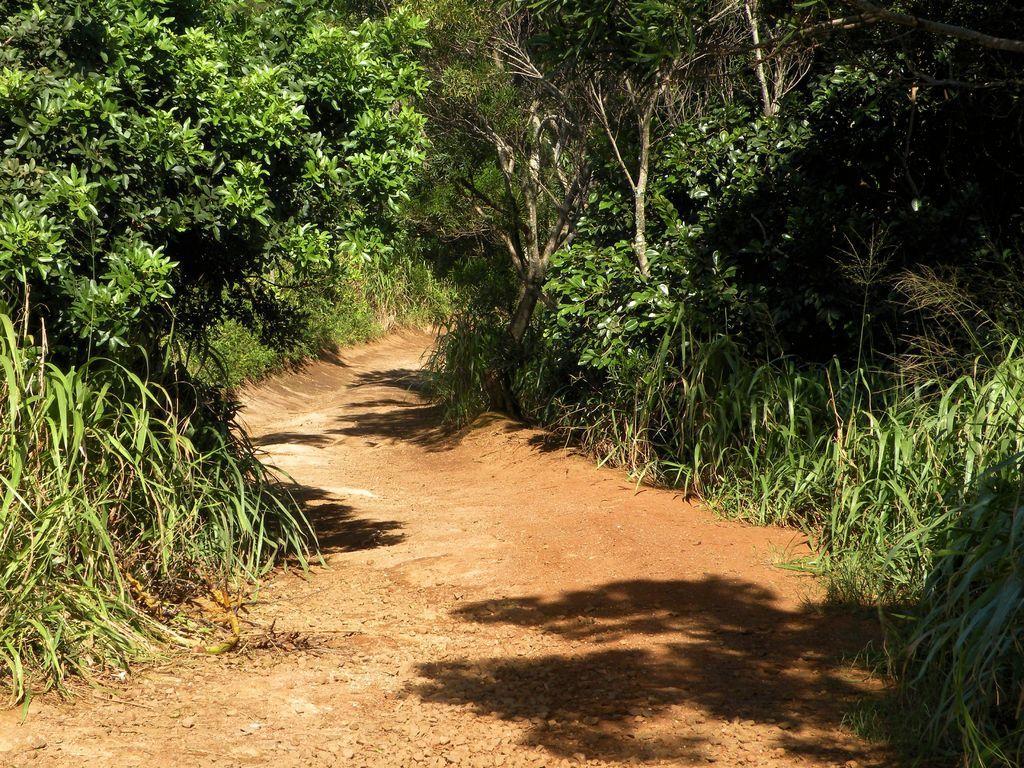How would you summarize this image in a sentence or two? In this picture I can see a path, there are plants and trees. 